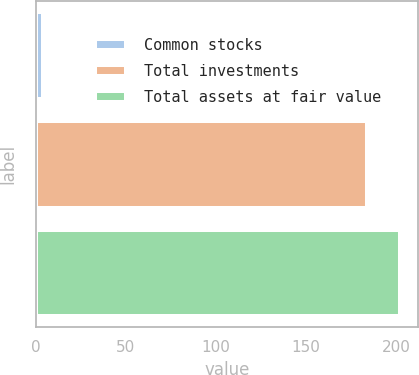Convert chart to OTSL. <chart><loc_0><loc_0><loc_500><loc_500><bar_chart><fcel>Common stocks<fcel>Total investments<fcel>Total assets at fair value<nl><fcel>4<fcel>184<fcel>202<nl></chart> 